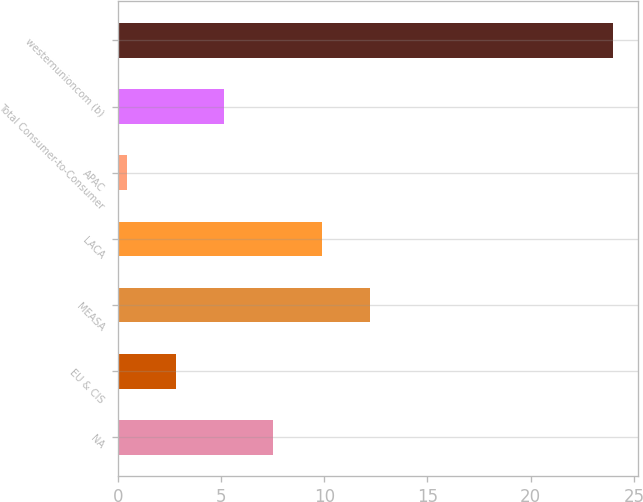<chart> <loc_0><loc_0><loc_500><loc_500><bar_chart><fcel>NA<fcel>EU & CIS<fcel>MEASA<fcel>LACA<fcel>APAC<fcel>Total Consumer-to-Consumer<fcel>westernunioncom (b)<nl><fcel>7.52<fcel>2.82<fcel>12.22<fcel>9.87<fcel>0.47<fcel>5.17<fcel>24<nl></chart> 